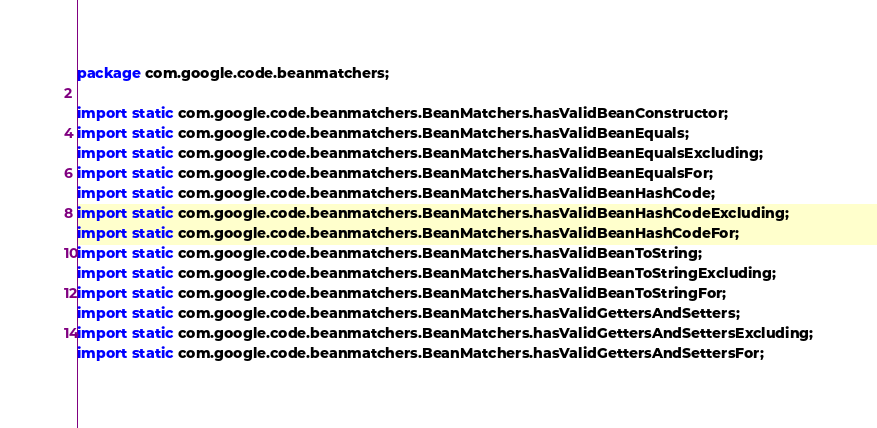Convert code to text. <code><loc_0><loc_0><loc_500><loc_500><_Java_>package com.google.code.beanmatchers;

import static com.google.code.beanmatchers.BeanMatchers.hasValidBeanConstructor;
import static com.google.code.beanmatchers.BeanMatchers.hasValidBeanEquals;
import static com.google.code.beanmatchers.BeanMatchers.hasValidBeanEqualsExcluding;
import static com.google.code.beanmatchers.BeanMatchers.hasValidBeanEqualsFor;
import static com.google.code.beanmatchers.BeanMatchers.hasValidBeanHashCode;
import static com.google.code.beanmatchers.BeanMatchers.hasValidBeanHashCodeExcluding;
import static com.google.code.beanmatchers.BeanMatchers.hasValidBeanHashCodeFor;
import static com.google.code.beanmatchers.BeanMatchers.hasValidBeanToString;
import static com.google.code.beanmatchers.BeanMatchers.hasValidBeanToStringExcluding;
import static com.google.code.beanmatchers.BeanMatchers.hasValidBeanToStringFor;
import static com.google.code.beanmatchers.BeanMatchers.hasValidGettersAndSetters;
import static com.google.code.beanmatchers.BeanMatchers.hasValidGettersAndSettersExcluding;
import static com.google.code.beanmatchers.BeanMatchers.hasValidGettersAndSettersFor;</code> 